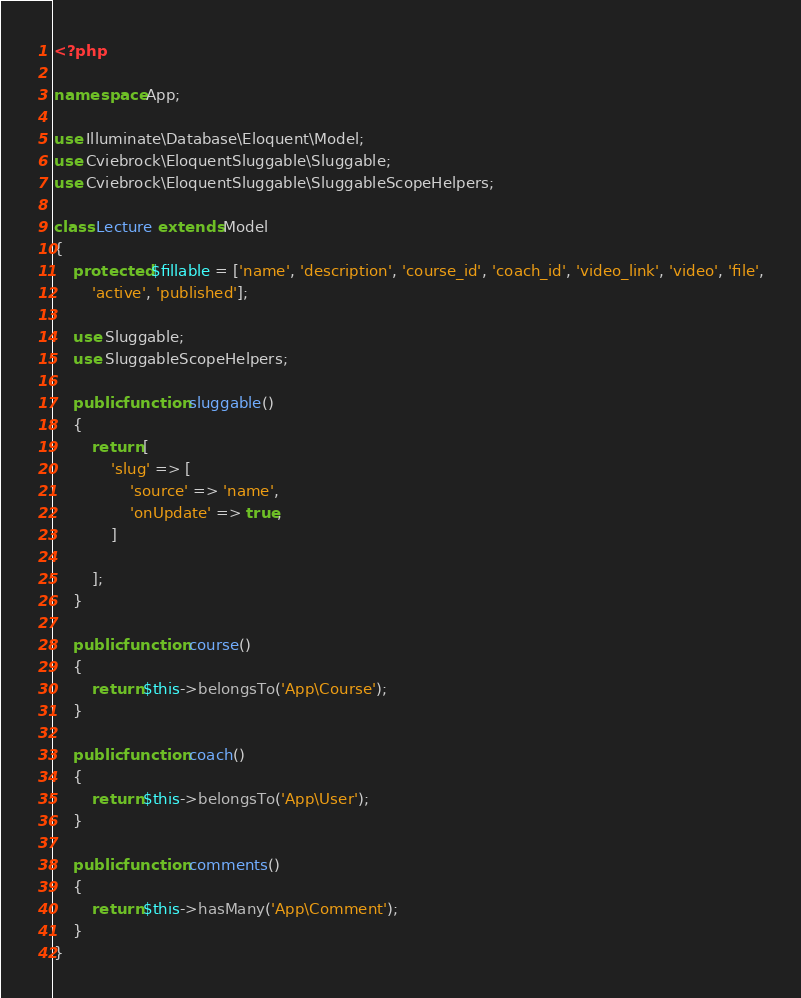<code> <loc_0><loc_0><loc_500><loc_500><_PHP_><?php

namespace App;

use Illuminate\Database\Eloquent\Model;
use Cviebrock\EloquentSluggable\Sluggable;
use Cviebrock\EloquentSluggable\SluggableScopeHelpers;

class Lecture extends Model
{
    protected $fillable = ['name', 'description', 'course_id', 'coach_id', 'video_link', 'video', 'file',
        'active', 'published'];

    use Sluggable;
    use SluggableScopeHelpers;

    public function sluggable()
    {
        return [
            'slug' => [
                'source' => 'name',
                'onUpdate' => true,
            ]

        ];
    }

    public function course()
    {
        return $this->belongsTo('App\Course');
    }

    public function coach()
    {
        return $this->belongsTo('App\User');
    }

    public function comments()
    {
        return $this->hasMany('App\Comment');
    }
}
</code> 